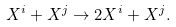<formula> <loc_0><loc_0><loc_500><loc_500>X ^ { i } + X ^ { j } \rightarrow 2 X ^ { i } + X ^ { j } .</formula> 